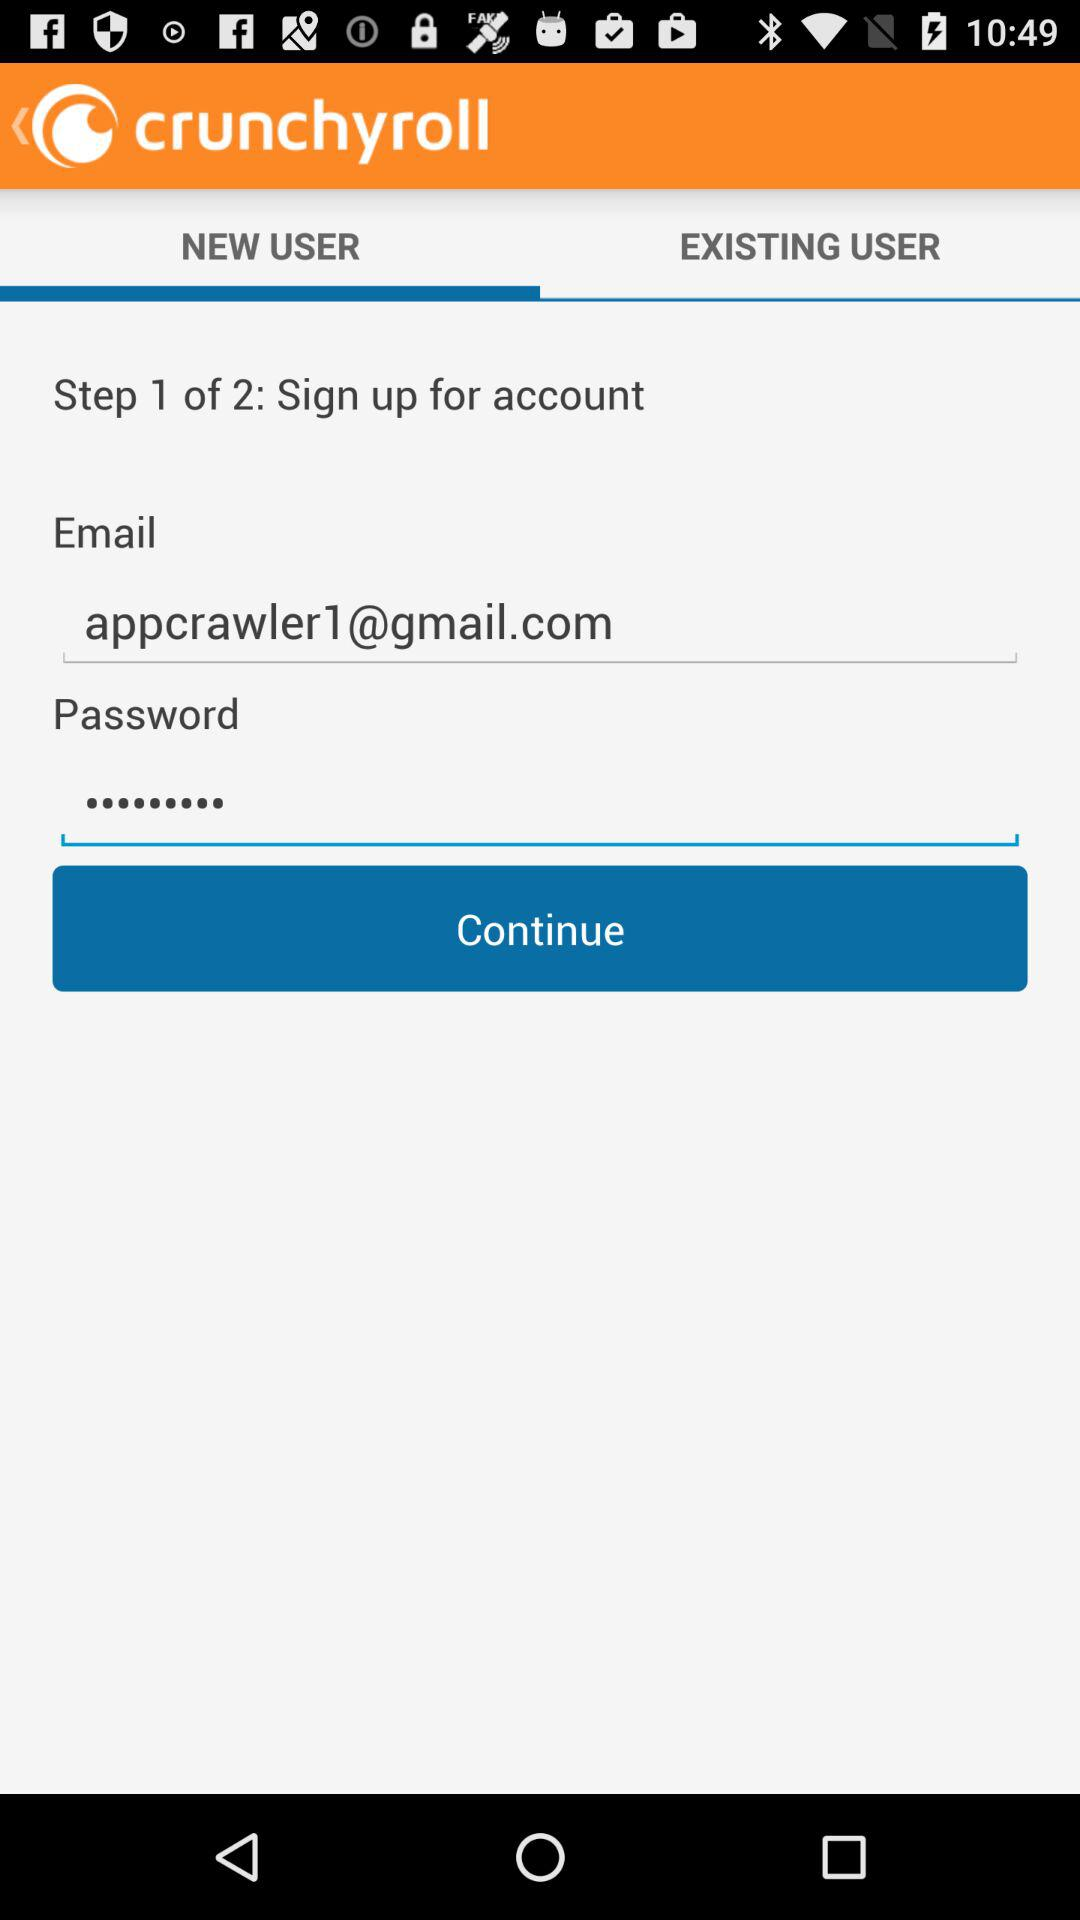How many steps in total are there? There are 2 steps. 